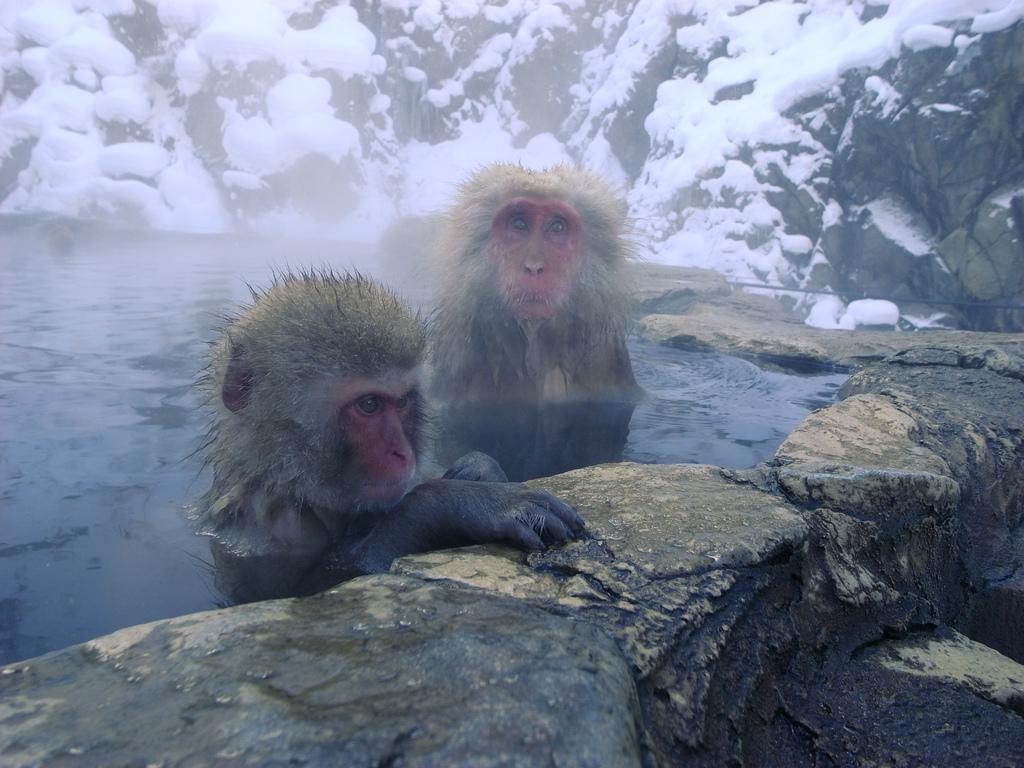Describe this image in one or two sentences. In this image there are two monkeys in the water by keeping their hands on the stone. In the background there are stones on which there are stones. 